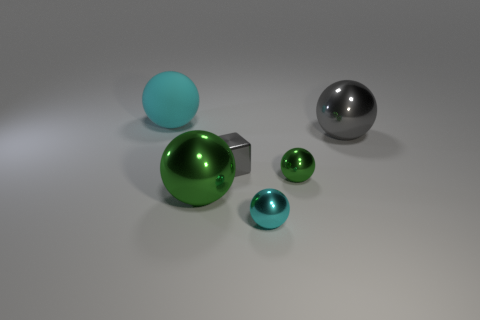Subtract all gray balls. How many balls are left? 4 Subtract all tiny green metal spheres. How many spheres are left? 4 Subtract all blue balls. Subtract all brown cylinders. How many balls are left? 5 Add 2 large yellow blocks. How many objects exist? 8 Subtract all balls. How many objects are left? 1 Subtract all small shiny balls. Subtract all gray shiny cylinders. How many objects are left? 4 Add 3 small green metal balls. How many small green metal balls are left? 4 Add 6 tiny blue rubber objects. How many tiny blue rubber objects exist? 6 Subtract 0 yellow blocks. How many objects are left? 6 